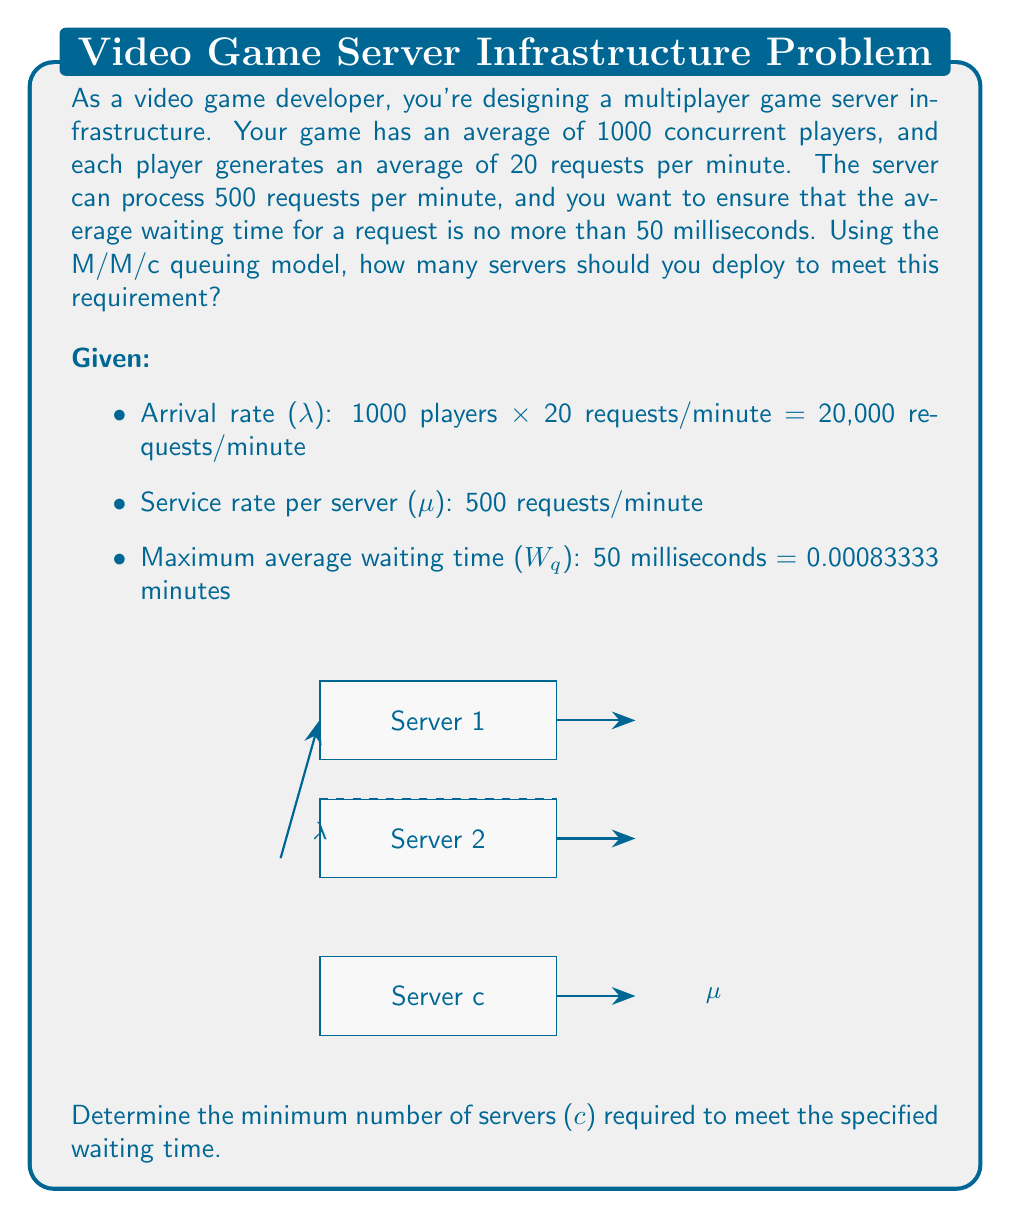Can you answer this question? To solve this problem, we'll use the M/M/c queuing model and iterate through different values of c until we find the minimum number of servers that satisfies our waiting time requirement.

Step 1: Calculate the utilization factor ρ
$$\rho = \frac{\lambda}{c\mu}$$

Step 2: Calculate P_0 (probability of an empty system)
$$P_0 = \left[\sum_{n=0}^{c-1}\frac{(c\rho)^n}{n!} + \frac{(c\rho)^c}{c!(1-\rho)}\right]^{-1}$$

Step 3: Calculate L_q (average number of customers in the queue)
$$L_q = \frac{P_0(c\rho)^c\rho}{c!(1-\rho)^2}$$

Step 4: Calculate W_q (average waiting time in the queue)
$$W_q = \frac{L_q}{\lambda}$$

We'll start with c = 40 (since λ/μ = 40) and increase c until W_q ≤ 0.00083333 minutes.

For c = 40:
ρ = 20000 / (40 * 500) = 1 (system is unstable)

For c = 41:
ρ = 20000 / (41 * 500) ≈ 0.9756
P_0 ≈ 1.5347e-42
L_q ≈ 929.8741
W_q ≈ 0.0465 minutes (too high)

Continuing this process, we find:

For c = 45:
ρ ≈ 0.8889
P_0 ≈ 7.0123e-46
L_q ≈ 16.6667
W_q ≈ 0.000833 minutes

This satisfies our requirement of W_q ≤ 0.00083333 minutes.
Answer: 45 servers 